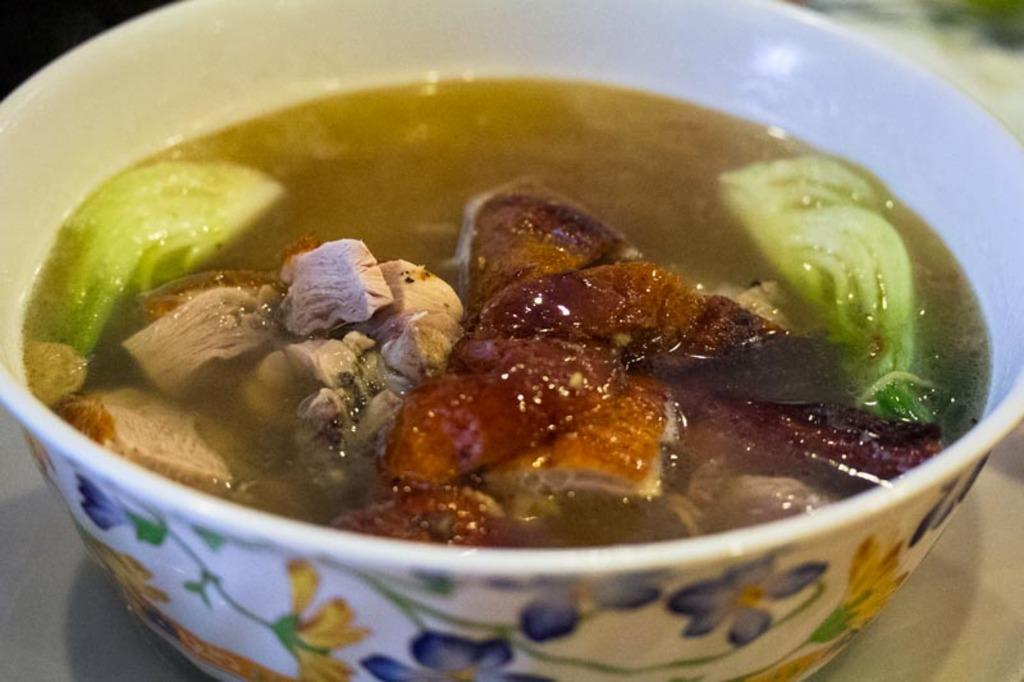What is present in the image? There is a bowl in the image. What is the bowl placed on? The bowl is on an object. What is inside the bowl? There are food items in the bowl, specifically soup. What type of potato is being used as a secretary in the image? There is no potato or secretary present in the image. 